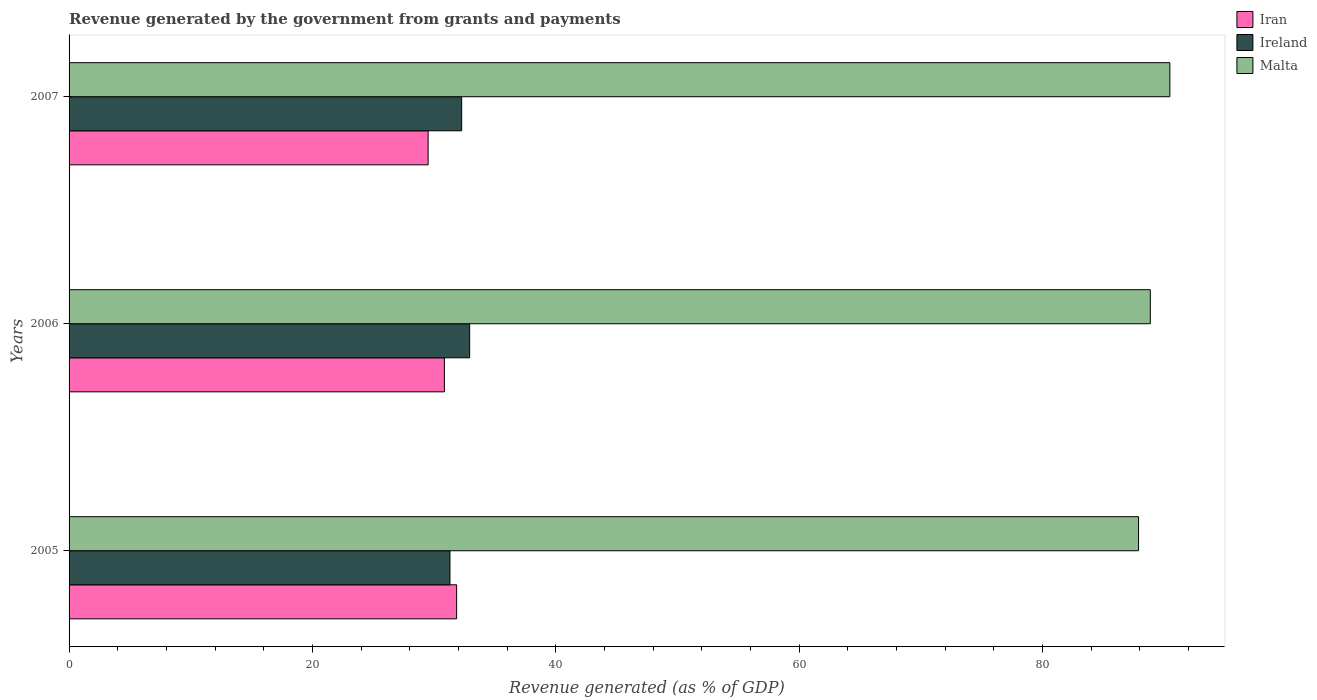How many bars are there on the 1st tick from the top?
Your answer should be compact. 3. In how many cases, is the number of bars for a given year not equal to the number of legend labels?
Ensure brevity in your answer.  0. What is the revenue generated by the government in Iran in 2005?
Your answer should be compact. 31.85. Across all years, what is the maximum revenue generated by the government in Ireland?
Your answer should be compact. 32.92. Across all years, what is the minimum revenue generated by the government in Iran?
Ensure brevity in your answer.  29.51. In which year was the revenue generated by the government in Malta maximum?
Make the answer very short. 2007. In which year was the revenue generated by the government in Iran minimum?
Ensure brevity in your answer.  2007. What is the total revenue generated by the government in Ireland in the graph?
Your answer should be very brief. 96.48. What is the difference between the revenue generated by the government in Malta in 2006 and that in 2007?
Ensure brevity in your answer.  -1.61. What is the difference between the revenue generated by the government in Ireland in 2005 and the revenue generated by the government in Iran in 2007?
Offer a very short reply. 1.79. What is the average revenue generated by the government in Malta per year?
Ensure brevity in your answer.  89.07. In the year 2005, what is the difference between the revenue generated by the government in Malta and revenue generated by the government in Iran?
Keep it short and to the point. 56.04. What is the ratio of the revenue generated by the government in Ireland in 2005 to that in 2006?
Provide a short and direct response. 0.95. Is the difference between the revenue generated by the government in Malta in 2005 and 2006 greater than the difference between the revenue generated by the government in Iran in 2005 and 2006?
Make the answer very short. No. What is the difference between the highest and the second highest revenue generated by the government in Ireland?
Ensure brevity in your answer.  0.66. What is the difference between the highest and the lowest revenue generated by the government in Malta?
Offer a terse response. 2.57. What does the 1st bar from the top in 2006 represents?
Provide a succinct answer. Malta. What does the 1st bar from the bottom in 2007 represents?
Offer a terse response. Iran. What is the difference between two consecutive major ticks on the X-axis?
Offer a terse response. 20. Does the graph contain any zero values?
Ensure brevity in your answer.  No. Where does the legend appear in the graph?
Give a very brief answer. Top right. How many legend labels are there?
Provide a succinct answer. 3. What is the title of the graph?
Ensure brevity in your answer.  Revenue generated by the government from grants and payments. What is the label or title of the X-axis?
Your answer should be compact. Revenue generated (as % of GDP). What is the Revenue generated (as % of GDP) of Iran in 2005?
Provide a succinct answer. 31.85. What is the Revenue generated (as % of GDP) in Ireland in 2005?
Provide a succinct answer. 31.3. What is the Revenue generated (as % of GDP) of Malta in 2005?
Your answer should be compact. 87.89. What is the Revenue generated (as % of GDP) of Iran in 2006?
Provide a short and direct response. 30.84. What is the Revenue generated (as % of GDP) of Ireland in 2006?
Your answer should be compact. 32.92. What is the Revenue generated (as % of GDP) of Malta in 2006?
Make the answer very short. 88.85. What is the Revenue generated (as % of GDP) of Iran in 2007?
Your answer should be compact. 29.51. What is the Revenue generated (as % of GDP) of Ireland in 2007?
Provide a short and direct response. 32.26. What is the Revenue generated (as % of GDP) of Malta in 2007?
Ensure brevity in your answer.  90.46. Across all years, what is the maximum Revenue generated (as % of GDP) of Iran?
Make the answer very short. 31.85. Across all years, what is the maximum Revenue generated (as % of GDP) of Ireland?
Your answer should be compact. 32.92. Across all years, what is the maximum Revenue generated (as % of GDP) in Malta?
Your response must be concise. 90.46. Across all years, what is the minimum Revenue generated (as % of GDP) in Iran?
Your response must be concise. 29.51. Across all years, what is the minimum Revenue generated (as % of GDP) of Ireland?
Your answer should be very brief. 31.3. Across all years, what is the minimum Revenue generated (as % of GDP) in Malta?
Keep it short and to the point. 87.89. What is the total Revenue generated (as % of GDP) of Iran in the graph?
Keep it short and to the point. 92.2. What is the total Revenue generated (as % of GDP) in Ireland in the graph?
Ensure brevity in your answer.  96.48. What is the total Revenue generated (as % of GDP) of Malta in the graph?
Your answer should be very brief. 267.2. What is the difference between the Revenue generated (as % of GDP) of Iran in 2005 and that in 2006?
Ensure brevity in your answer.  1.01. What is the difference between the Revenue generated (as % of GDP) of Ireland in 2005 and that in 2006?
Keep it short and to the point. -1.62. What is the difference between the Revenue generated (as % of GDP) in Malta in 2005 and that in 2006?
Your answer should be very brief. -0.97. What is the difference between the Revenue generated (as % of GDP) in Iran in 2005 and that in 2007?
Keep it short and to the point. 2.34. What is the difference between the Revenue generated (as % of GDP) of Ireland in 2005 and that in 2007?
Your answer should be compact. -0.96. What is the difference between the Revenue generated (as % of GDP) in Malta in 2005 and that in 2007?
Your answer should be compact. -2.57. What is the difference between the Revenue generated (as % of GDP) in Iran in 2006 and that in 2007?
Offer a terse response. 1.34. What is the difference between the Revenue generated (as % of GDP) of Ireland in 2006 and that in 2007?
Keep it short and to the point. 0.66. What is the difference between the Revenue generated (as % of GDP) in Malta in 2006 and that in 2007?
Your response must be concise. -1.61. What is the difference between the Revenue generated (as % of GDP) in Iran in 2005 and the Revenue generated (as % of GDP) in Ireland in 2006?
Ensure brevity in your answer.  -1.07. What is the difference between the Revenue generated (as % of GDP) of Iran in 2005 and the Revenue generated (as % of GDP) of Malta in 2006?
Your answer should be very brief. -57. What is the difference between the Revenue generated (as % of GDP) of Ireland in 2005 and the Revenue generated (as % of GDP) of Malta in 2006?
Your response must be concise. -57.55. What is the difference between the Revenue generated (as % of GDP) in Iran in 2005 and the Revenue generated (as % of GDP) in Ireland in 2007?
Your response must be concise. -0.41. What is the difference between the Revenue generated (as % of GDP) in Iran in 2005 and the Revenue generated (as % of GDP) in Malta in 2007?
Give a very brief answer. -58.61. What is the difference between the Revenue generated (as % of GDP) of Ireland in 2005 and the Revenue generated (as % of GDP) of Malta in 2007?
Make the answer very short. -59.16. What is the difference between the Revenue generated (as % of GDP) of Iran in 2006 and the Revenue generated (as % of GDP) of Ireland in 2007?
Offer a very short reply. -1.42. What is the difference between the Revenue generated (as % of GDP) in Iran in 2006 and the Revenue generated (as % of GDP) in Malta in 2007?
Offer a terse response. -59.62. What is the difference between the Revenue generated (as % of GDP) in Ireland in 2006 and the Revenue generated (as % of GDP) in Malta in 2007?
Give a very brief answer. -57.54. What is the average Revenue generated (as % of GDP) of Iran per year?
Your response must be concise. 30.73. What is the average Revenue generated (as % of GDP) of Ireland per year?
Your answer should be very brief. 32.16. What is the average Revenue generated (as % of GDP) of Malta per year?
Provide a succinct answer. 89.07. In the year 2005, what is the difference between the Revenue generated (as % of GDP) in Iran and Revenue generated (as % of GDP) in Ireland?
Give a very brief answer. 0.55. In the year 2005, what is the difference between the Revenue generated (as % of GDP) of Iran and Revenue generated (as % of GDP) of Malta?
Offer a very short reply. -56.04. In the year 2005, what is the difference between the Revenue generated (as % of GDP) in Ireland and Revenue generated (as % of GDP) in Malta?
Keep it short and to the point. -56.58. In the year 2006, what is the difference between the Revenue generated (as % of GDP) of Iran and Revenue generated (as % of GDP) of Ireland?
Ensure brevity in your answer.  -2.08. In the year 2006, what is the difference between the Revenue generated (as % of GDP) of Iran and Revenue generated (as % of GDP) of Malta?
Provide a succinct answer. -58.01. In the year 2006, what is the difference between the Revenue generated (as % of GDP) of Ireland and Revenue generated (as % of GDP) of Malta?
Give a very brief answer. -55.93. In the year 2007, what is the difference between the Revenue generated (as % of GDP) of Iran and Revenue generated (as % of GDP) of Ireland?
Keep it short and to the point. -2.76. In the year 2007, what is the difference between the Revenue generated (as % of GDP) of Iran and Revenue generated (as % of GDP) of Malta?
Provide a short and direct response. -60.95. In the year 2007, what is the difference between the Revenue generated (as % of GDP) of Ireland and Revenue generated (as % of GDP) of Malta?
Ensure brevity in your answer.  -58.2. What is the ratio of the Revenue generated (as % of GDP) in Iran in 2005 to that in 2006?
Your response must be concise. 1.03. What is the ratio of the Revenue generated (as % of GDP) of Ireland in 2005 to that in 2006?
Make the answer very short. 0.95. What is the ratio of the Revenue generated (as % of GDP) of Malta in 2005 to that in 2006?
Give a very brief answer. 0.99. What is the ratio of the Revenue generated (as % of GDP) in Iran in 2005 to that in 2007?
Provide a short and direct response. 1.08. What is the ratio of the Revenue generated (as % of GDP) of Ireland in 2005 to that in 2007?
Keep it short and to the point. 0.97. What is the ratio of the Revenue generated (as % of GDP) in Malta in 2005 to that in 2007?
Keep it short and to the point. 0.97. What is the ratio of the Revenue generated (as % of GDP) in Iran in 2006 to that in 2007?
Give a very brief answer. 1.05. What is the ratio of the Revenue generated (as % of GDP) of Ireland in 2006 to that in 2007?
Give a very brief answer. 1.02. What is the ratio of the Revenue generated (as % of GDP) of Malta in 2006 to that in 2007?
Give a very brief answer. 0.98. What is the difference between the highest and the second highest Revenue generated (as % of GDP) in Iran?
Provide a short and direct response. 1.01. What is the difference between the highest and the second highest Revenue generated (as % of GDP) of Ireland?
Keep it short and to the point. 0.66. What is the difference between the highest and the second highest Revenue generated (as % of GDP) of Malta?
Your response must be concise. 1.61. What is the difference between the highest and the lowest Revenue generated (as % of GDP) of Iran?
Your answer should be compact. 2.34. What is the difference between the highest and the lowest Revenue generated (as % of GDP) of Ireland?
Offer a terse response. 1.62. What is the difference between the highest and the lowest Revenue generated (as % of GDP) in Malta?
Your answer should be compact. 2.57. 